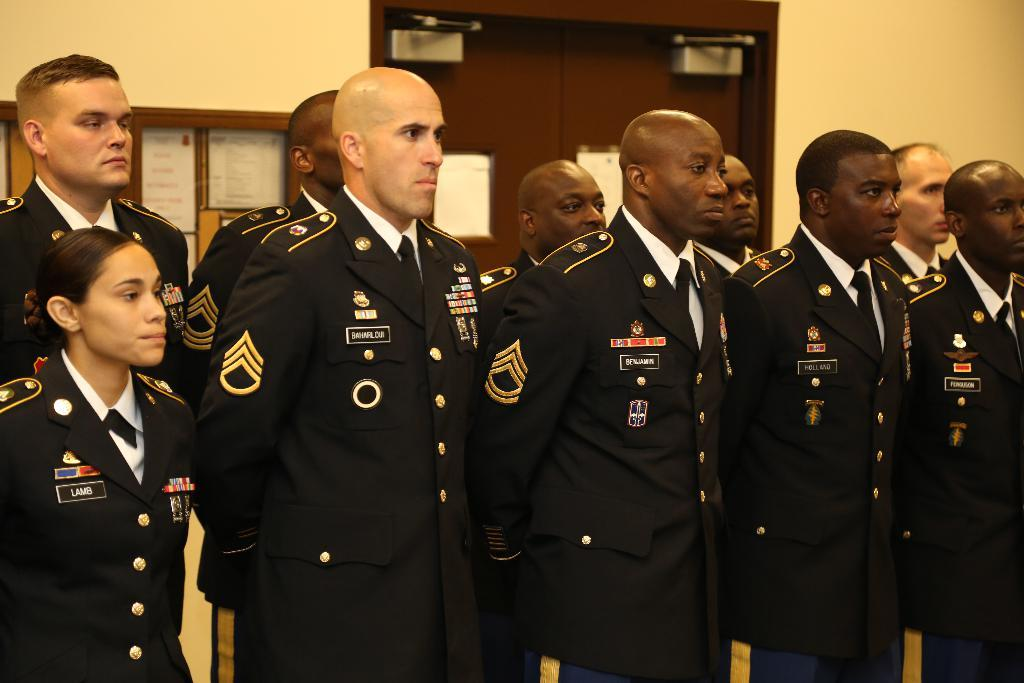What can be seen in the image? There are people standing in the image. What are the people wearing? The people are wearing black coats. What is visible in the background of the image? There is a notice board, a brown door, and a wall in the background of the image. What type of fuel is being used by the maid in the image? There is no maid or fuel present in the image. How many bags can be seen on the wall in the image? There are no bags visible on the wall in the image. 